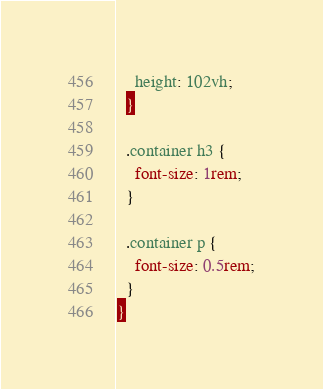Convert code to text. <code><loc_0><loc_0><loc_500><loc_500><_CSS_>    height: 102vh;
  }

  .container h3 {
    font-size: 1rem;
  }

  .container p {
    font-size: 0.5rem;
  }
}
</code> 